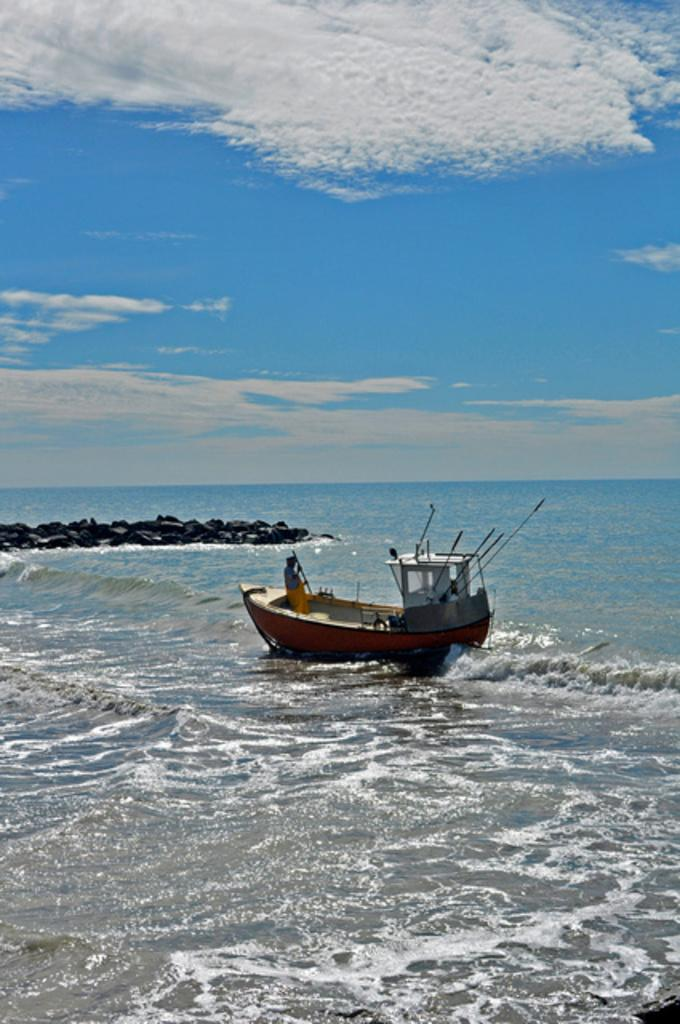What is the main feature of the image? There is water in the image. What is on the water? There is a boat on the water. Who or what is on the boat? There is a person on the boat. What is located to the left of the boat? There are rocks to the left of the boat. What can be seen above the water and boat? The sky is visible at the top of the image. What color is the gun that the person on the boat is holding? There is no gun present in the image; the person on the boat is not holding any weapon. 